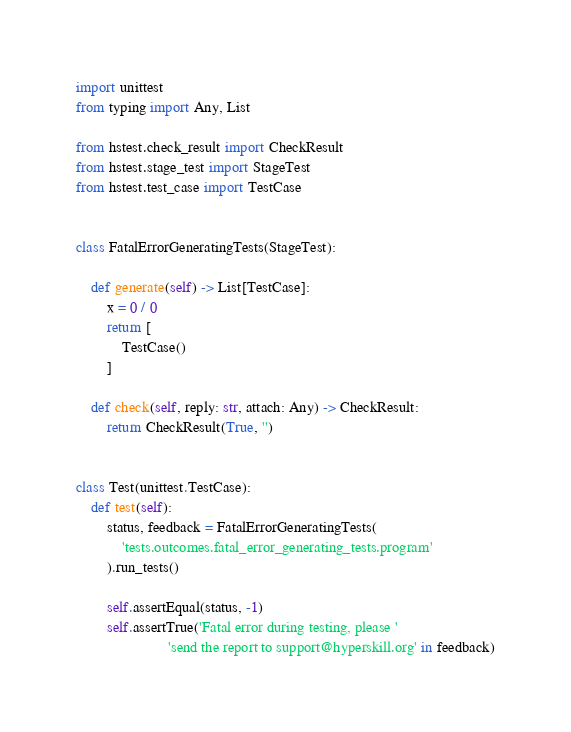<code> <loc_0><loc_0><loc_500><loc_500><_Python_>import unittest
from typing import Any, List

from hstest.check_result import CheckResult
from hstest.stage_test import StageTest
from hstest.test_case import TestCase


class FatalErrorGeneratingTests(StageTest):

    def generate(self) -> List[TestCase]:
        x = 0 / 0
        return [
            TestCase()
        ]

    def check(self, reply: str, attach: Any) -> CheckResult:
        return CheckResult(True, '')


class Test(unittest.TestCase):
    def test(self):
        status, feedback = FatalErrorGeneratingTests(
            'tests.outcomes.fatal_error_generating_tests.program'
        ).run_tests()

        self.assertEqual(status, -1)
        self.assertTrue('Fatal error during testing, please '
                        'send the report to support@hyperskill.org' in feedback)
</code> 